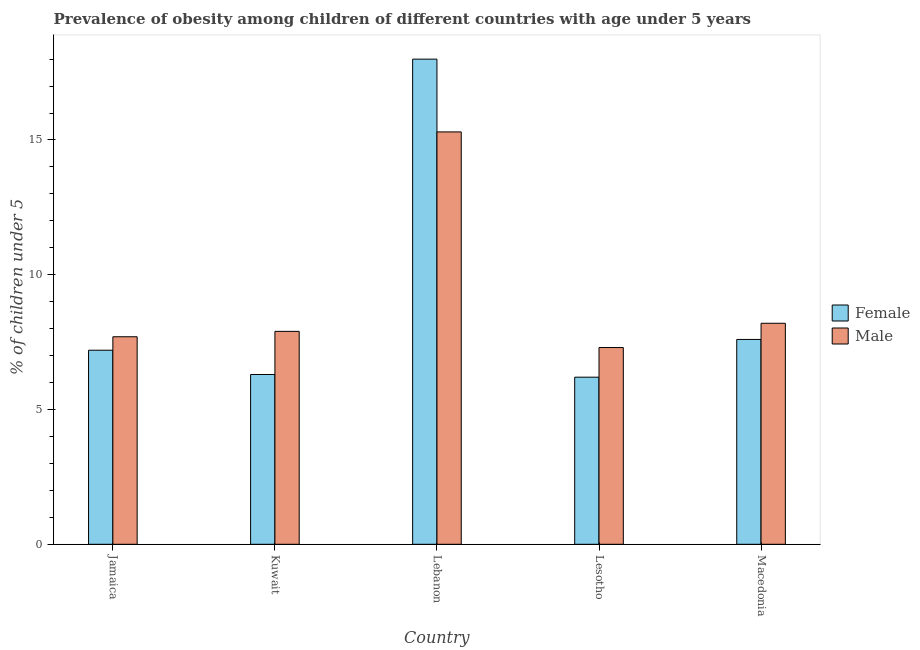How many groups of bars are there?
Provide a succinct answer. 5. Are the number of bars on each tick of the X-axis equal?
Your answer should be compact. Yes. How many bars are there on the 2nd tick from the left?
Ensure brevity in your answer.  2. What is the label of the 1st group of bars from the left?
Give a very brief answer. Jamaica. What is the percentage of obese female children in Jamaica?
Make the answer very short. 7.2. Across all countries, what is the maximum percentage of obese female children?
Give a very brief answer. 18. Across all countries, what is the minimum percentage of obese female children?
Your answer should be compact. 6.2. In which country was the percentage of obese female children maximum?
Offer a very short reply. Lebanon. In which country was the percentage of obese female children minimum?
Your response must be concise. Lesotho. What is the total percentage of obese male children in the graph?
Give a very brief answer. 46.4. What is the difference between the percentage of obese male children in Lebanon and that in Macedonia?
Your answer should be very brief. 7.1. What is the difference between the percentage of obese male children in Lebanon and the percentage of obese female children in Jamaica?
Give a very brief answer. 8.1. What is the average percentage of obese male children per country?
Provide a succinct answer. 9.28. What is the difference between the percentage of obese female children and percentage of obese male children in Jamaica?
Keep it short and to the point. -0.5. In how many countries, is the percentage of obese male children greater than 7 %?
Offer a terse response. 5. What is the ratio of the percentage of obese male children in Lebanon to that in Macedonia?
Give a very brief answer. 1.87. Is the difference between the percentage of obese female children in Jamaica and Macedonia greater than the difference between the percentage of obese male children in Jamaica and Macedonia?
Offer a very short reply. Yes. What is the difference between the highest and the second highest percentage of obese male children?
Offer a terse response. 7.1. What is the difference between the highest and the lowest percentage of obese female children?
Provide a succinct answer. 11.8. In how many countries, is the percentage of obese male children greater than the average percentage of obese male children taken over all countries?
Provide a succinct answer. 1. Is the sum of the percentage of obese male children in Kuwait and Lebanon greater than the maximum percentage of obese female children across all countries?
Offer a very short reply. Yes. What does the 2nd bar from the right in Macedonia represents?
Ensure brevity in your answer.  Female. Does the graph contain grids?
Your response must be concise. No. How are the legend labels stacked?
Ensure brevity in your answer.  Vertical. What is the title of the graph?
Your response must be concise. Prevalence of obesity among children of different countries with age under 5 years. What is the label or title of the X-axis?
Offer a terse response. Country. What is the label or title of the Y-axis?
Offer a very short reply.  % of children under 5. What is the  % of children under 5 in Female in Jamaica?
Ensure brevity in your answer.  7.2. What is the  % of children under 5 in Male in Jamaica?
Offer a very short reply. 7.7. What is the  % of children under 5 of Female in Kuwait?
Your answer should be very brief. 6.3. What is the  % of children under 5 in Male in Kuwait?
Ensure brevity in your answer.  7.9. What is the  % of children under 5 of Male in Lebanon?
Your response must be concise. 15.3. What is the  % of children under 5 in Female in Lesotho?
Ensure brevity in your answer.  6.2. What is the  % of children under 5 in Male in Lesotho?
Keep it short and to the point. 7.3. Across all countries, what is the maximum  % of children under 5 in Male?
Provide a succinct answer. 15.3. Across all countries, what is the minimum  % of children under 5 in Female?
Provide a succinct answer. 6.2. Across all countries, what is the minimum  % of children under 5 in Male?
Your answer should be very brief. 7.3. What is the total  % of children under 5 in Female in the graph?
Provide a succinct answer. 45.3. What is the total  % of children under 5 of Male in the graph?
Offer a very short reply. 46.4. What is the difference between the  % of children under 5 in Female in Jamaica and that in Kuwait?
Keep it short and to the point. 0.9. What is the difference between the  % of children under 5 of Female in Jamaica and that in Lebanon?
Your answer should be very brief. -10.8. What is the difference between the  % of children under 5 in Male in Jamaica and that in Lebanon?
Provide a succinct answer. -7.6. What is the difference between the  % of children under 5 in Female in Jamaica and that in Lesotho?
Offer a terse response. 1. What is the difference between the  % of children under 5 in Male in Jamaica and that in Lesotho?
Your answer should be very brief. 0.4. What is the difference between the  % of children under 5 of Female in Jamaica and that in Macedonia?
Provide a succinct answer. -0.4. What is the difference between the  % of children under 5 of Male in Jamaica and that in Macedonia?
Provide a succinct answer. -0.5. What is the difference between the  % of children under 5 in Female in Kuwait and that in Macedonia?
Ensure brevity in your answer.  -1.3. What is the difference between the  % of children under 5 in Male in Lebanon and that in Macedonia?
Your response must be concise. 7.1. What is the difference between the  % of children under 5 in Female in Jamaica and the  % of children under 5 in Male in Kuwait?
Your answer should be compact. -0.7. What is the difference between the  % of children under 5 of Female in Jamaica and the  % of children under 5 of Male in Lebanon?
Your response must be concise. -8.1. What is the difference between the  % of children under 5 of Female in Jamaica and the  % of children under 5 of Male in Macedonia?
Ensure brevity in your answer.  -1. What is the difference between the  % of children under 5 in Female in Kuwait and the  % of children under 5 in Male in Lesotho?
Your response must be concise. -1. What is the difference between the  % of children under 5 in Female in Lebanon and the  % of children under 5 in Male in Lesotho?
Your answer should be compact. 10.7. What is the difference between the  % of children under 5 in Female in Lesotho and the  % of children under 5 in Male in Macedonia?
Make the answer very short. -2. What is the average  % of children under 5 in Female per country?
Provide a succinct answer. 9.06. What is the average  % of children under 5 of Male per country?
Offer a terse response. 9.28. What is the difference between the  % of children under 5 in Female and  % of children under 5 in Male in Jamaica?
Provide a short and direct response. -0.5. What is the difference between the  % of children under 5 of Female and  % of children under 5 of Male in Kuwait?
Provide a short and direct response. -1.6. What is the difference between the  % of children under 5 of Female and  % of children under 5 of Male in Macedonia?
Your response must be concise. -0.6. What is the ratio of the  % of children under 5 in Female in Jamaica to that in Kuwait?
Your response must be concise. 1.14. What is the ratio of the  % of children under 5 of Male in Jamaica to that in Kuwait?
Make the answer very short. 0.97. What is the ratio of the  % of children under 5 of Male in Jamaica to that in Lebanon?
Your answer should be compact. 0.5. What is the ratio of the  % of children under 5 in Female in Jamaica to that in Lesotho?
Your response must be concise. 1.16. What is the ratio of the  % of children under 5 in Male in Jamaica to that in Lesotho?
Your answer should be very brief. 1.05. What is the ratio of the  % of children under 5 in Male in Jamaica to that in Macedonia?
Offer a very short reply. 0.94. What is the ratio of the  % of children under 5 of Female in Kuwait to that in Lebanon?
Your answer should be compact. 0.35. What is the ratio of the  % of children under 5 in Male in Kuwait to that in Lebanon?
Make the answer very short. 0.52. What is the ratio of the  % of children under 5 in Female in Kuwait to that in Lesotho?
Your response must be concise. 1.02. What is the ratio of the  % of children under 5 in Male in Kuwait to that in Lesotho?
Your answer should be very brief. 1.08. What is the ratio of the  % of children under 5 in Female in Kuwait to that in Macedonia?
Offer a very short reply. 0.83. What is the ratio of the  % of children under 5 of Male in Kuwait to that in Macedonia?
Your answer should be very brief. 0.96. What is the ratio of the  % of children under 5 of Female in Lebanon to that in Lesotho?
Give a very brief answer. 2.9. What is the ratio of the  % of children under 5 in Male in Lebanon to that in Lesotho?
Offer a very short reply. 2.1. What is the ratio of the  % of children under 5 in Female in Lebanon to that in Macedonia?
Provide a short and direct response. 2.37. What is the ratio of the  % of children under 5 in Male in Lebanon to that in Macedonia?
Provide a succinct answer. 1.87. What is the ratio of the  % of children under 5 in Female in Lesotho to that in Macedonia?
Make the answer very short. 0.82. What is the ratio of the  % of children under 5 in Male in Lesotho to that in Macedonia?
Keep it short and to the point. 0.89. What is the difference between the highest and the second highest  % of children under 5 in Female?
Make the answer very short. 10.4. 